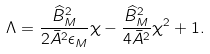Convert formula to latex. <formula><loc_0><loc_0><loc_500><loc_500>\Lambda = \frac { \widehat { B } _ { M } ^ { 2 } } { 2 \bar { A } ^ { 2 } \epsilon _ { M } } \chi - \frac { \widehat { B } _ { M } ^ { 2 } } { 4 \bar { A } ^ { 2 } } \chi ^ { 2 } + 1 .</formula> 